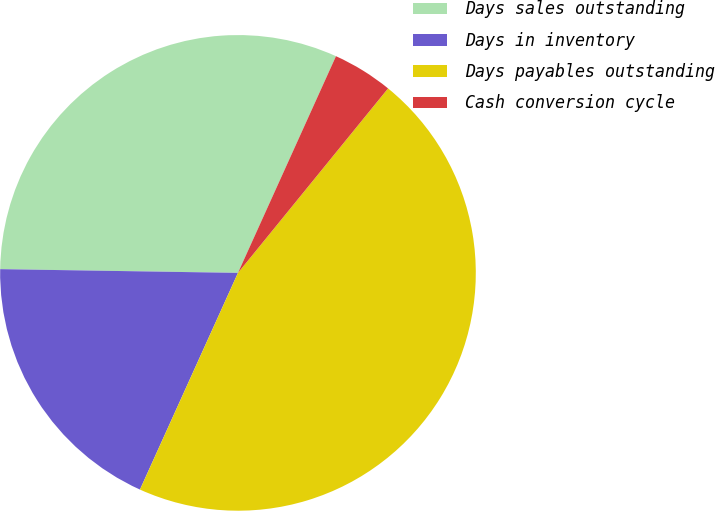Convert chart. <chart><loc_0><loc_0><loc_500><loc_500><pie_chart><fcel>Days sales outstanding<fcel>Days in inventory<fcel>Days payables outstanding<fcel>Cash conversion cycle<nl><fcel>31.51%<fcel>18.49%<fcel>45.89%<fcel>4.11%<nl></chart> 